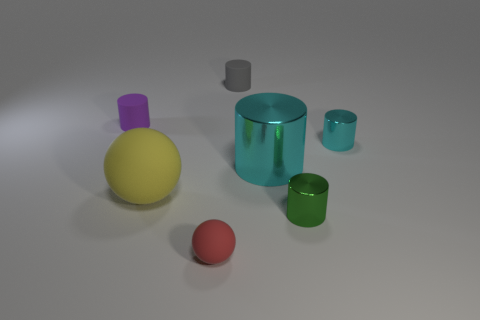There is a cyan cylinder behind the large cyan object; what material is it?
Offer a terse response. Metal. The purple object is what size?
Offer a terse response. Small. Do the rubber cylinder in front of the small gray rubber object and the cyan shiny cylinder that is on the right side of the large cyan metal object have the same size?
Your answer should be very brief. Yes. There is a purple object that is the same shape as the tiny cyan object; what is its size?
Provide a short and direct response. Small. Is the size of the green shiny thing the same as the thing to the right of the green thing?
Make the answer very short. Yes. Are there any metal cylinders that are behind the rubber object behind the purple cylinder?
Offer a terse response. No. The big object that is to the left of the small gray matte cylinder has what shape?
Provide a succinct answer. Sphere. What is the material of the thing that is the same color as the big cylinder?
Give a very brief answer. Metal. What color is the tiny metal cylinder to the left of the tiny metal cylinder behind the large yellow sphere?
Your answer should be compact. Green. Is the size of the gray cylinder the same as the purple cylinder?
Provide a short and direct response. Yes. 